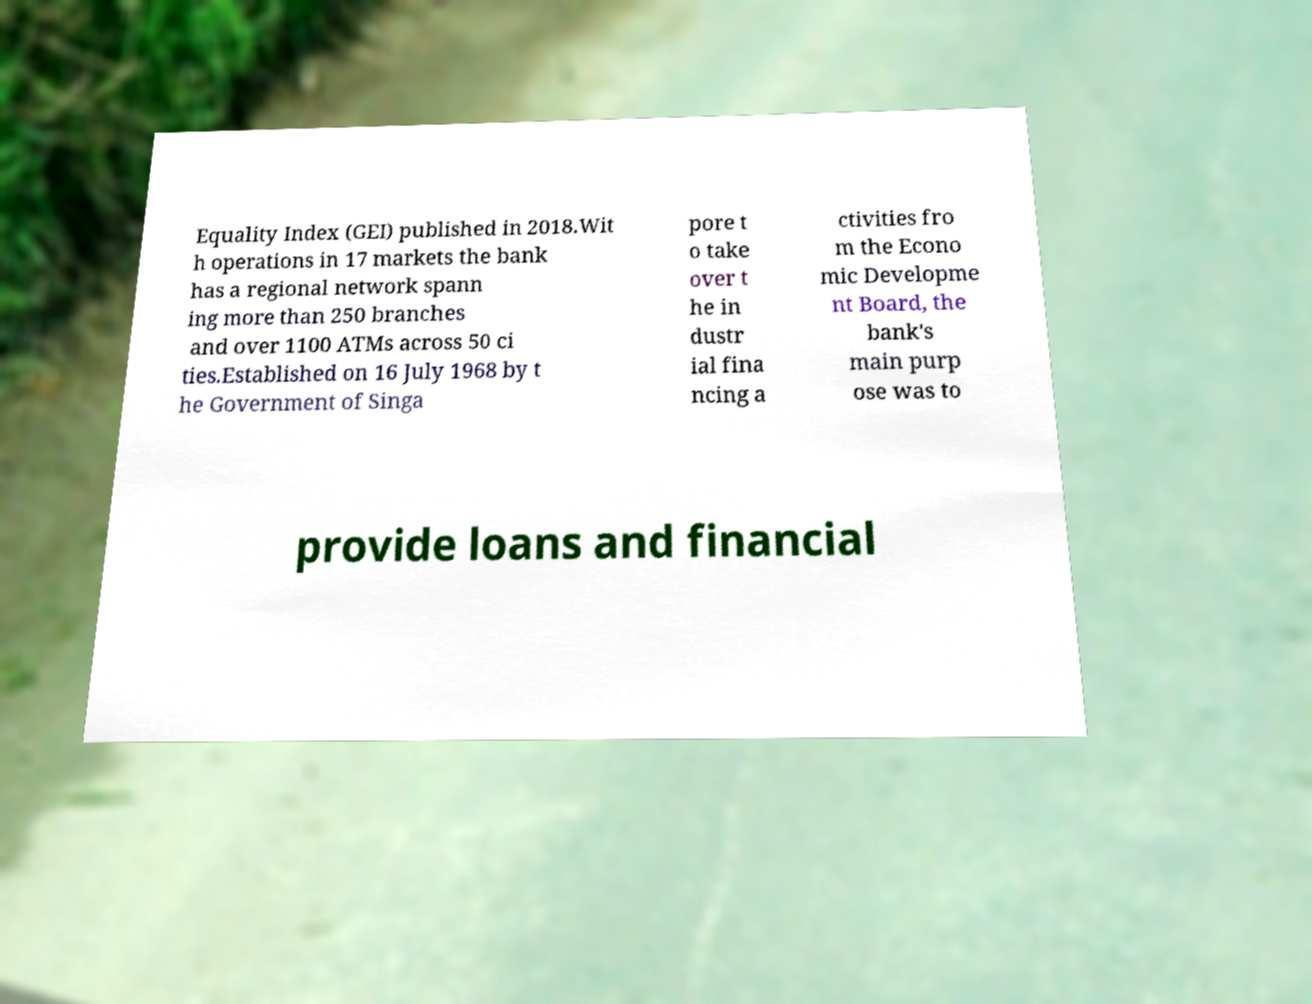For documentation purposes, I need the text within this image transcribed. Could you provide that? Equality Index (GEI) published in 2018.Wit h operations in 17 markets the bank has a regional network spann ing more than 250 branches and over 1100 ATMs across 50 ci ties.Established on 16 July 1968 by t he Government of Singa pore t o take over t he in dustr ial fina ncing a ctivities fro m the Econo mic Developme nt Board, the bank's main purp ose was to provide loans and financial 